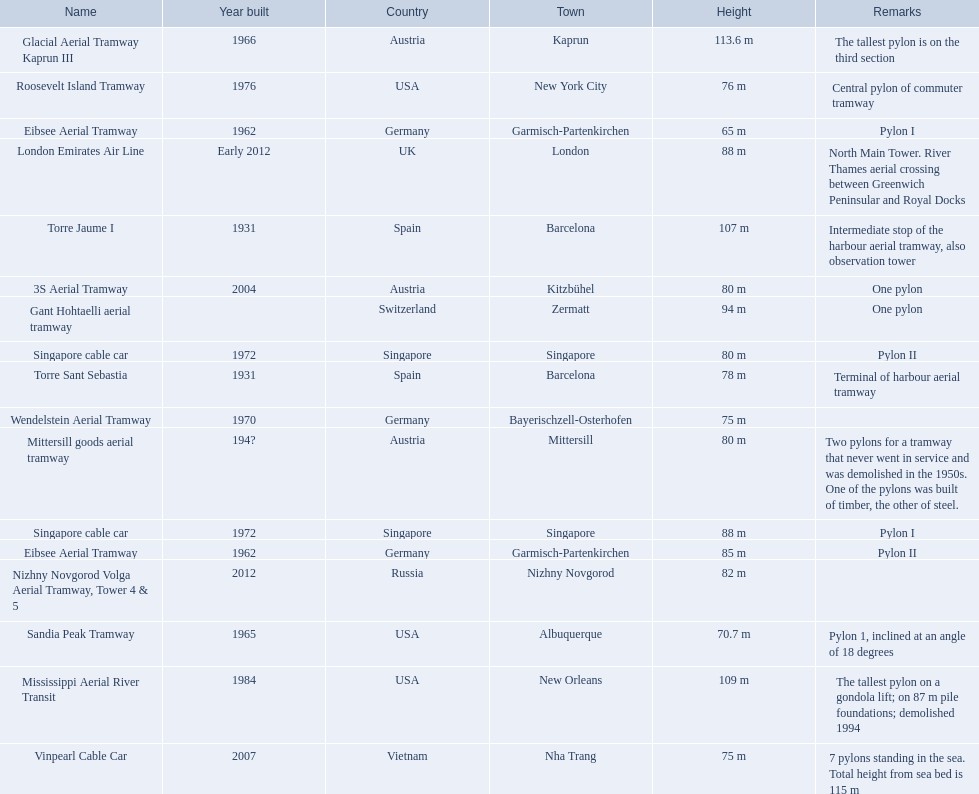Which lift has the second highest height? Mississippi Aerial River Transit. What is the value of the height? 109 m. 